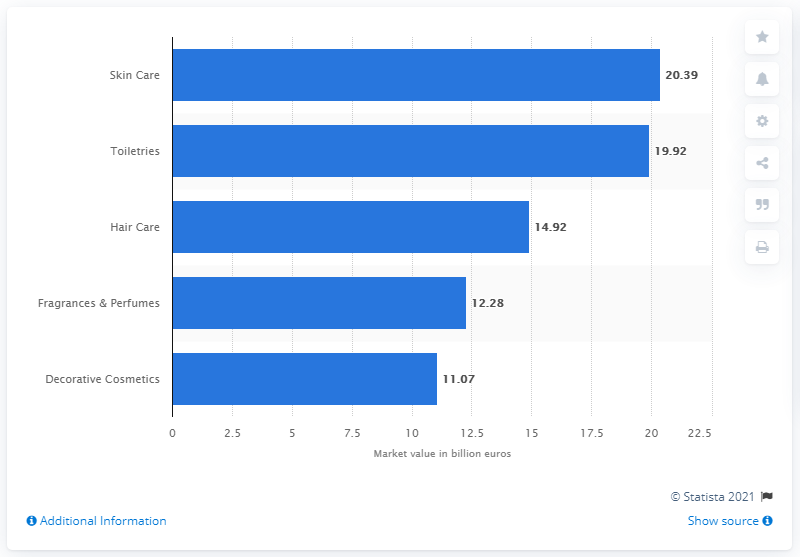Specify some key components in this picture. The market value of skin care in 2018 was 20.39 million. 